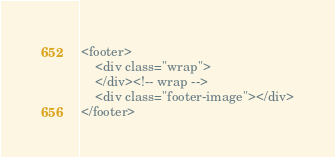<code> <loc_0><loc_0><loc_500><loc_500><_PHP_><footer>
    <div class="wrap">
    </div><!-- wrap -->
    <div class="footer-image"></div>
</footer></code> 